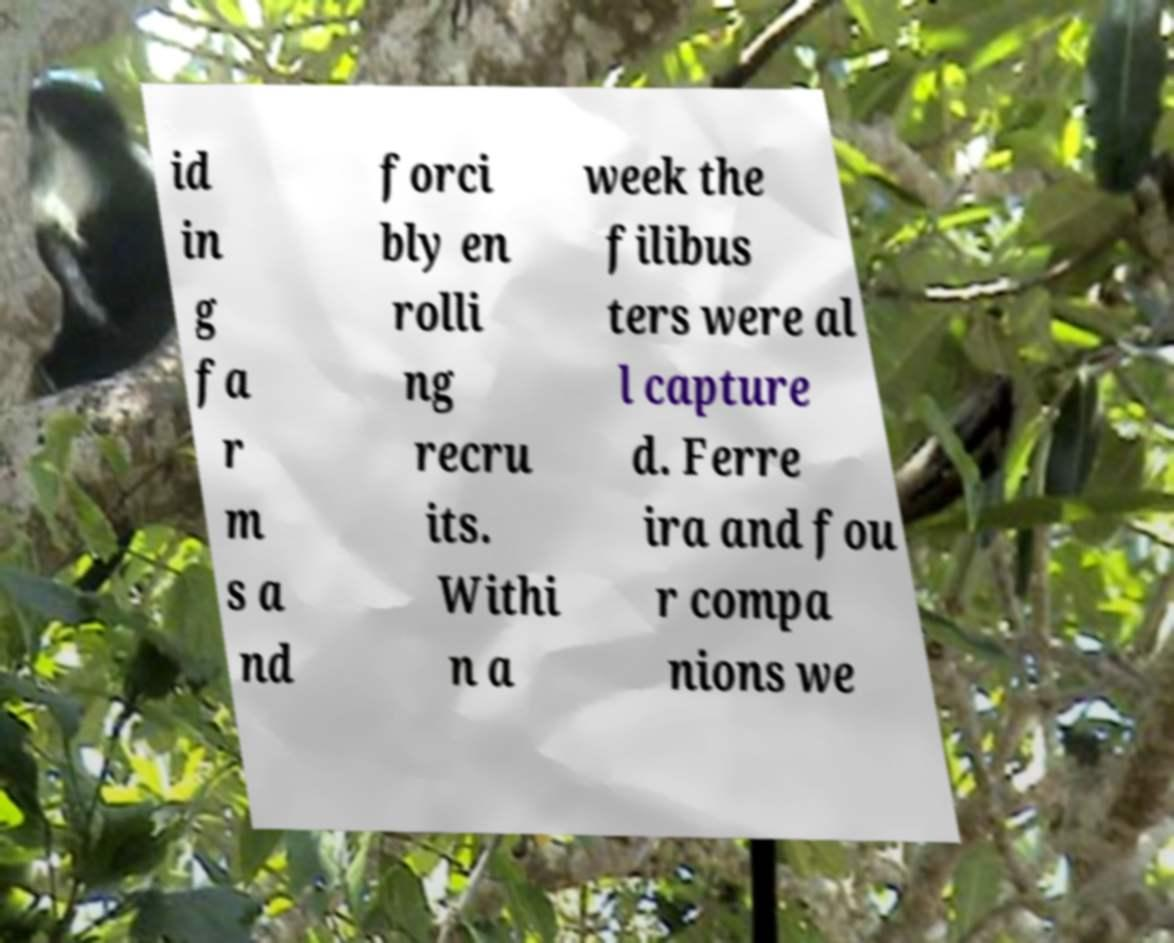What messages or text are displayed in this image? I need them in a readable, typed format. id in g fa r m s a nd forci bly en rolli ng recru its. Withi n a week the filibus ters were al l capture d. Ferre ira and fou r compa nions we 